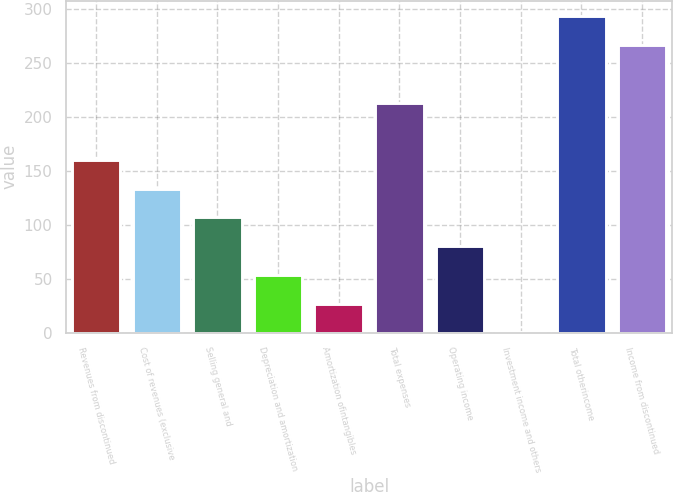Convert chart. <chart><loc_0><loc_0><loc_500><loc_500><bar_chart><fcel>Revenues from discontinued<fcel>Cost of revenues (exclusive<fcel>Selling general and<fcel>Depreciation and amortization<fcel>Amortization ofintangibles<fcel>Total expenses<fcel>Operating income<fcel>Investment income and others<fcel>Total otherincome<fcel>Income from discontinued<nl><fcel>159.74<fcel>133.15<fcel>106.56<fcel>53.38<fcel>26.79<fcel>212.92<fcel>79.97<fcel>0.2<fcel>292.69<fcel>266.1<nl></chart> 